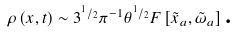<formula> <loc_0><loc_0><loc_500><loc_500>\rho \left ( x , t \right ) \sim 3 ^ { ^ { 1 } / _ { 2 } } \pi ^ { - 1 } \theta ^ { ^ { 1 } / _ { 2 } } F \left [ \tilde { x } _ { a } , \tilde { \omega } _ { a } \right ] \text {.}</formula> 